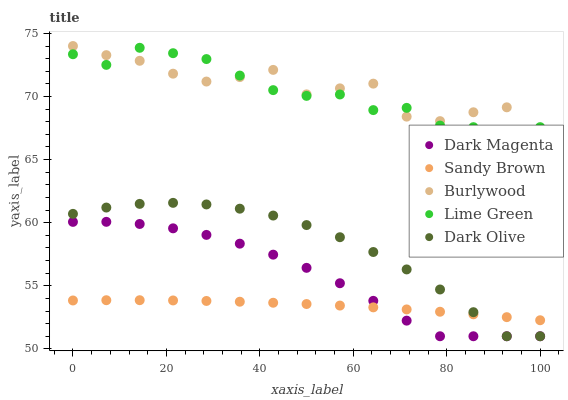Does Sandy Brown have the minimum area under the curve?
Answer yes or no. Yes. Does Burlywood have the maximum area under the curve?
Answer yes or no. Yes. Does Lime Green have the minimum area under the curve?
Answer yes or no. No. Does Lime Green have the maximum area under the curve?
Answer yes or no. No. Is Sandy Brown the smoothest?
Answer yes or no. Yes. Is Burlywood the roughest?
Answer yes or no. Yes. Is Lime Green the smoothest?
Answer yes or no. No. Is Lime Green the roughest?
Answer yes or no. No. Does Dark Olive have the lowest value?
Answer yes or no. Yes. Does Lime Green have the lowest value?
Answer yes or no. No. Does Burlywood have the highest value?
Answer yes or no. Yes. Does Lime Green have the highest value?
Answer yes or no. No. Is Dark Olive less than Burlywood?
Answer yes or no. Yes. Is Burlywood greater than Sandy Brown?
Answer yes or no. Yes. Does Dark Magenta intersect Dark Olive?
Answer yes or no. Yes. Is Dark Magenta less than Dark Olive?
Answer yes or no. No. Is Dark Magenta greater than Dark Olive?
Answer yes or no. No. Does Dark Olive intersect Burlywood?
Answer yes or no. No. 